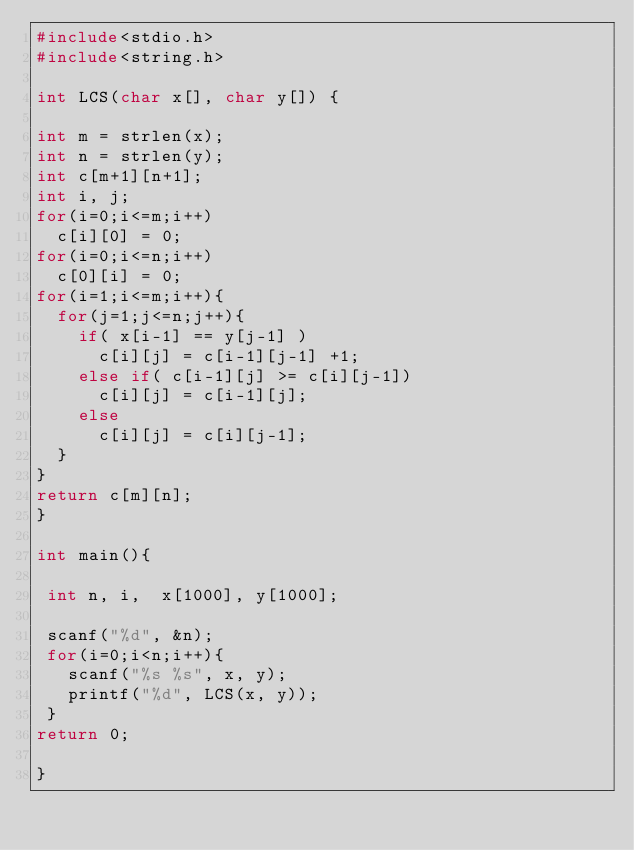Convert code to text. <code><loc_0><loc_0><loc_500><loc_500><_C_>#include<stdio.h>
#include<string.h>

int LCS(char x[], char y[]) {

int m = strlen(x);
int n = strlen(y);
int c[m+1][n+1];
int i, j;
for(i=0;i<=m;i++) 
  c[i][0] = 0;
for(i=0;i<=n;i++)
  c[0][i] = 0;
for(i=1;i<=m;i++){
  for(j=1;j<=n;j++){
    if( x[i-1] == y[j-1] )
      c[i][j] = c[i-1][j-1] +1;
    else if( c[i-1][j] >= c[i][j-1])
      c[i][j] = c[i-1][j];
    else 
      c[i][j] = c[i][j-1];
  }
}
return c[m][n];
}

int main(){

 int n, i,  x[1000], y[1000];
 
 scanf("%d", &n);
 for(i=0;i<n;i++){
   scanf("%s %s", x, y);
   printf("%d", LCS(x, y));
 }
return 0;

}</code> 